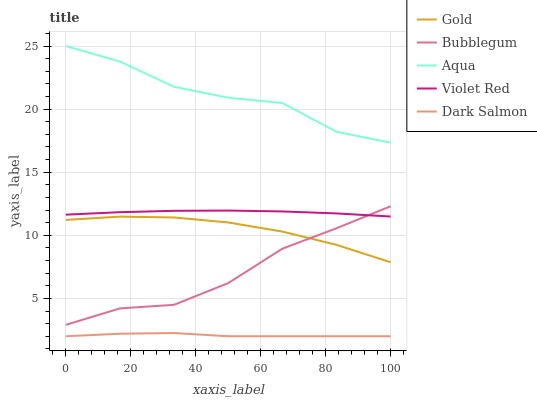Does Dark Salmon have the minimum area under the curve?
Answer yes or no. Yes. Does Aqua have the maximum area under the curve?
Answer yes or no. Yes. Does Bubblegum have the minimum area under the curve?
Answer yes or no. No. Does Bubblegum have the maximum area under the curve?
Answer yes or no. No. Is Violet Red the smoothest?
Answer yes or no. Yes. Is Aqua the roughest?
Answer yes or no. Yes. Is Bubblegum the smoothest?
Answer yes or no. No. Is Bubblegum the roughest?
Answer yes or no. No. Does Dark Salmon have the lowest value?
Answer yes or no. Yes. Does Bubblegum have the lowest value?
Answer yes or no. No. Does Aqua have the highest value?
Answer yes or no. Yes. Does Bubblegum have the highest value?
Answer yes or no. No. Is Gold less than Violet Red?
Answer yes or no. Yes. Is Aqua greater than Dark Salmon?
Answer yes or no. Yes. Does Violet Red intersect Bubblegum?
Answer yes or no. Yes. Is Violet Red less than Bubblegum?
Answer yes or no. No. Is Violet Red greater than Bubblegum?
Answer yes or no. No. Does Gold intersect Violet Red?
Answer yes or no. No. 